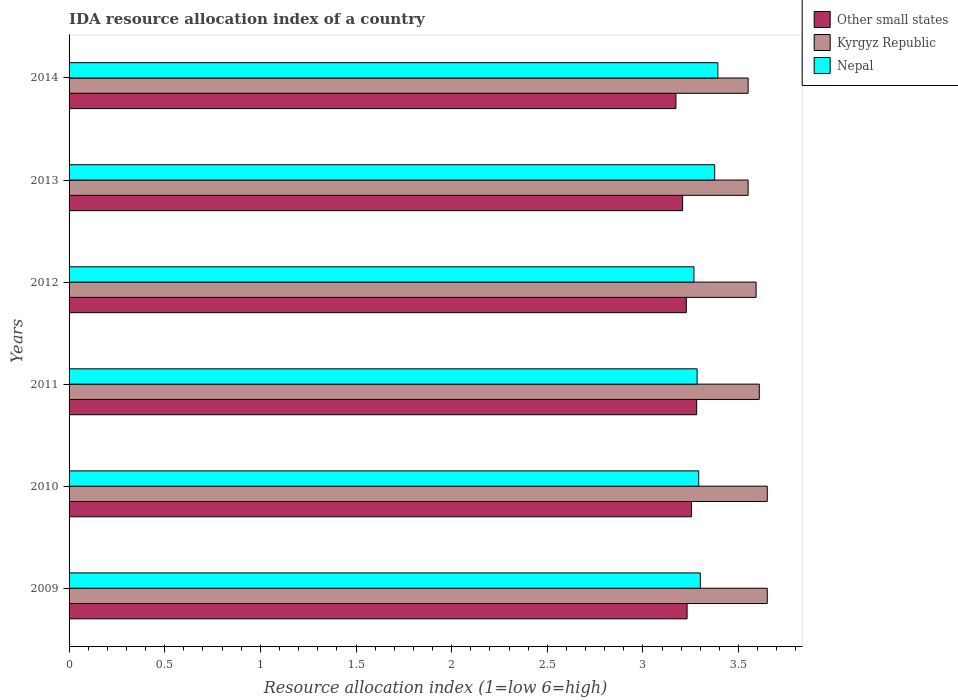How many groups of bars are there?
Offer a terse response. 6. Are the number of bars per tick equal to the number of legend labels?
Keep it short and to the point. Yes. Are the number of bars on each tick of the Y-axis equal?
Provide a succinct answer. Yes. How many bars are there on the 3rd tick from the top?
Your response must be concise. 3. How many bars are there on the 2nd tick from the bottom?
Make the answer very short. 3. What is the label of the 6th group of bars from the top?
Make the answer very short. 2009. What is the IDA resource allocation index in Kyrgyz Republic in 2012?
Make the answer very short. 3.59. Across all years, what is the maximum IDA resource allocation index in Kyrgyz Republic?
Offer a very short reply. 3.65. Across all years, what is the minimum IDA resource allocation index in Kyrgyz Republic?
Give a very brief answer. 3.55. What is the total IDA resource allocation index in Nepal in the graph?
Your answer should be very brief. 19.91. What is the difference between the IDA resource allocation index in Other small states in 2010 and that in 2013?
Ensure brevity in your answer.  0.05. What is the difference between the IDA resource allocation index in Other small states in 2009 and the IDA resource allocation index in Kyrgyz Republic in 2011?
Provide a succinct answer. -0.38. What is the average IDA resource allocation index in Other small states per year?
Ensure brevity in your answer.  3.23. In the year 2011, what is the difference between the IDA resource allocation index in Other small states and IDA resource allocation index in Kyrgyz Republic?
Provide a succinct answer. -0.33. In how many years, is the IDA resource allocation index in Nepal greater than 2.6 ?
Offer a very short reply. 6. What is the ratio of the IDA resource allocation index in Nepal in 2011 to that in 2014?
Provide a short and direct response. 0.97. What is the difference between the highest and the second highest IDA resource allocation index in Other small states?
Keep it short and to the point. 0.03. What is the difference between the highest and the lowest IDA resource allocation index in Nepal?
Your answer should be compact. 0.13. Is the sum of the IDA resource allocation index in Kyrgyz Republic in 2009 and 2010 greater than the maximum IDA resource allocation index in Nepal across all years?
Provide a succinct answer. Yes. What does the 1st bar from the top in 2011 represents?
Ensure brevity in your answer.  Nepal. What does the 2nd bar from the bottom in 2009 represents?
Ensure brevity in your answer.  Kyrgyz Republic. How many bars are there?
Your answer should be compact. 18. What is the difference between two consecutive major ticks on the X-axis?
Ensure brevity in your answer.  0.5. Does the graph contain any zero values?
Your answer should be compact. No. Where does the legend appear in the graph?
Make the answer very short. Top right. What is the title of the graph?
Offer a very short reply. IDA resource allocation index of a country. Does "Malaysia" appear as one of the legend labels in the graph?
Give a very brief answer. No. What is the label or title of the X-axis?
Provide a short and direct response. Resource allocation index (1=low 6=high). What is the Resource allocation index (1=low 6=high) in Other small states in 2009?
Make the answer very short. 3.23. What is the Resource allocation index (1=low 6=high) in Kyrgyz Republic in 2009?
Offer a terse response. 3.65. What is the Resource allocation index (1=low 6=high) in Other small states in 2010?
Keep it short and to the point. 3.25. What is the Resource allocation index (1=low 6=high) of Kyrgyz Republic in 2010?
Your answer should be very brief. 3.65. What is the Resource allocation index (1=low 6=high) of Nepal in 2010?
Your answer should be very brief. 3.29. What is the Resource allocation index (1=low 6=high) in Other small states in 2011?
Your answer should be very brief. 3.28. What is the Resource allocation index (1=low 6=high) in Kyrgyz Republic in 2011?
Your answer should be compact. 3.61. What is the Resource allocation index (1=low 6=high) of Nepal in 2011?
Make the answer very short. 3.28. What is the Resource allocation index (1=low 6=high) in Other small states in 2012?
Offer a very short reply. 3.23. What is the Resource allocation index (1=low 6=high) in Kyrgyz Republic in 2012?
Your response must be concise. 3.59. What is the Resource allocation index (1=low 6=high) in Nepal in 2012?
Your response must be concise. 3.27. What is the Resource allocation index (1=low 6=high) of Other small states in 2013?
Your answer should be compact. 3.21. What is the Resource allocation index (1=low 6=high) of Kyrgyz Republic in 2013?
Offer a very short reply. 3.55. What is the Resource allocation index (1=low 6=high) in Nepal in 2013?
Your answer should be very brief. 3.38. What is the Resource allocation index (1=low 6=high) in Other small states in 2014?
Your answer should be very brief. 3.17. What is the Resource allocation index (1=low 6=high) in Kyrgyz Republic in 2014?
Your response must be concise. 3.55. What is the Resource allocation index (1=low 6=high) of Nepal in 2014?
Offer a very short reply. 3.39. Across all years, what is the maximum Resource allocation index (1=low 6=high) in Other small states?
Offer a very short reply. 3.28. Across all years, what is the maximum Resource allocation index (1=low 6=high) of Kyrgyz Republic?
Make the answer very short. 3.65. Across all years, what is the maximum Resource allocation index (1=low 6=high) of Nepal?
Give a very brief answer. 3.39. Across all years, what is the minimum Resource allocation index (1=low 6=high) in Other small states?
Ensure brevity in your answer.  3.17. Across all years, what is the minimum Resource allocation index (1=low 6=high) of Kyrgyz Republic?
Give a very brief answer. 3.55. Across all years, what is the minimum Resource allocation index (1=low 6=high) of Nepal?
Give a very brief answer. 3.27. What is the total Resource allocation index (1=low 6=high) in Other small states in the graph?
Make the answer very short. 19.37. What is the total Resource allocation index (1=low 6=high) in Kyrgyz Republic in the graph?
Provide a succinct answer. 21.6. What is the total Resource allocation index (1=low 6=high) in Nepal in the graph?
Offer a very short reply. 19.91. What is the difference between the Resource allocation index (1=low 6=high) of Other small states in 2009 and that in 2010?
Offer a very short reply. -0.02. What is the difference between the Resource allocation index (1=low 6=high) of Kyrgyz Republic in 2009 and that in 2010?
Your answer should be very brief. 0. What is the difference between the Resource allocation index (1=low 6=high) of Nepal in 2009 and that in 2010?
Keep it short and to the point. 0.01. What is the difference between the Resource allocation index (1=low 6=high) of Other small states in 2009 and that in 2011?
Provide a succinct answer. -0.05. What is the difference between the Resource allocation index (1=low 6=high) in Kyrgyz Republic in 2009 and that in 2011?
Keep it short and to the point. 0.04. What is the difference between the Resource allocation index (1=low 6=high) of Nepal in 2009 and that in 2011?
Offer a very short reply. 0.02. What is the difference between the Resource allocation index (1=low 6=high) of Other small states in 2009 and that in 2012?
Offer a terse response. 0. What is the difference between the Resource allocation index (1=low 6=high) in Kyrgyz Republic in 2009 and that in 2012?
Offer a terse response. 0.06. What is the difference between the Resource allocation index (1=low 6=high) of Other small states in 2009 and that in 2013?
Make the answer very short. 0.02. What is the difference between the Resource allocation index (1=low 6=high) in Kyrgyz Republic in 2009 and that in 2013?
Your answer should be compact. 0.1. What is the difference between the Resource allocation index (1=low 6=high) of Nepal in 2009 and that in 2013?
Ensure brevity in your answer.  -0.07. What is the difference between the Resource allocation index (1=low 6=high) of Other small states in 2009 and that in 2014?
Provide a short and direct response. 0.06. What is the difference between the Resource allocation index (1=low 6=high) in Kyrgyz Republic in 2009 and that in 2014?
Your answer should be compact. 0.1. What is the difference between the Resource allocation index (1=low 6=high) of Nepal in 2009 and that in 2014?
Give a very brief answer. -0.09. What is the difference between the Resource allocation index (1=low 6=high) of Other small states in 2010 and that in 2011?
Your answer should be compact. -0.03. What is the difference between the Resource allocation index (1=low 6=high) of Kyrgyz Republic in 2010 and that in 2011?
Your answer should be compact. 0.04. What is the difference between the Resource allocation index (1=low 6=high) in Nepal in 2010 and that in 2011?
Provide a succinct answer. 0.01. What is the difference between the Resource allocation index (1=low 6=high) in Other small states in 2010 and that in 2012?
Make the answer very short. 0.03. What is the difference between the Resource allocation index (1=low 6=high) of Kyrgyz Republic in 2010 and that in 2012?
Make the answer very short. 0.06. What is the difference between the Resource allocation index (1=low 6=high) of Nepal in 2010 and that in 2012?
Give a very brief answer. 0.03. What is the difference between the Resource allocation index (1=low 6=high) in Other small states in 2010 and that in 2013?
Give a very brief answer. 0.05. What is the difference between the Resource allocation index (1=low 6=high) of Nepal in 2010 and that in 2013?
Make the answer very short. -0.08. What is the difference between the Resource allocation index (1=low 6=high) in Other small states in 2010 and that in 2014?
Make the answer very short. 0.08. What is the difference between the Resource allocation index (1=low 6=high) of Nepal in 2010 and that in 2014?
Give a very brief answer. -0.1. What is the difference between the Resource allocation index (1=low 6=high) in Other small states in 2011 and that in 2012?
Offer a very short reply. 0.05. What is the difference between the Resource allocation index (1=low 6=high) in Kyrgyz Republic in 2011 and that in 2012?
Ensure brevity in your answer.  0.02. What is the difference between the Resource allocation index (1=low 6=high) of Nepal in 2011 and that in 2012?
Your answer should be compact. 0.02. What is the difference between the Resource allocation index (1=low 6=high) in Other small states in 2011 and that in 2013?
Your answer should be compact. 0.07. What is the difference between the Resource allocation index (1=low 6=high) of Kyrgyz Republic in 2011 and that in 2013?
Give a very brief answer. 0.06. What is the difference between the Resource allocation index (1=low 6=high) in Nepal in 2011 and that in 2013?
Keep it short and to the point. -0.09. What is the difference between the Resource allocation index (1=low 6=high) of Other small states in 2011 and that in 2014?
Ensure brevity in your answer.  0.11. What is the difference between the Resource allocation index (1=low 6=high) of Kyrgyz Republic in 2011 and that in 2014?
Offer a very short reply. 0.06. What is the difference between the Resource allocation index (1=low 6=high) in Nepal in 2011 and that in 2014?
Give a very brief answer. -0.11. What is the difference between the Resource allocation index (1=low 6=high) in Other small states in 2012 and that in 2013?
Give a very brief answer. 0.02. What is the difference between the Resource allocation index (1=low 6=high) in Kyrgyz Republic in 2012 and that in 2013?
Your answer should be compact. 0.04. What is the difference between the Resource allocation index (1=low 6=high) in Nepal in 2012 and that in 2013?
Ensure brevity in your answer.  -0.11. What is the difference between the Resource allocation index (1=low 6=high) in Other small states in 2012 and that in 2014?
Offer a terse response. 0.05. What is the difference between the Resource allocation index (1=low 6=high) in Kyrgyz Republic in 2012 and that in 2014?
Your answer should be very brief. 0.04. What is the difference between the Resource allocation index (1=low 6=high) in Nepal in 2012 and that in 2014?
Your answer should be very brief. -0.12. What is the difference between the Resource allocation index (1=low 6=high) of Other small states in 2013 and that in 2014?
Your answer should be very brief. 0.04. What is the difference between the Resource allocation index (1=low 6=high) in Kyrgyz Republic in 2013 and that in 2014?
Make the answer very short. 0. What is the difference between the Resource allocation index (1=low 6=high) in Nepal in 2013 and that in 2014?
Offer a terse response. -0.02. What is the difference between the Resource allocation index (1=low 6=high) of Other small states in 2009 and the Resource allocation index (1=low 6=high) of Kyrgyz Republic in 2010?
Your response must be concise. -0.42. What is the difference between the Resource allocation index (1=low 6=high) of Other small states in 2009 and the Resource allocation index (1=low 6=high) of Nepal in 2010?
Your response must be concise. -0.06. What is the difference between the Resource allocation index (1=low 6=high) in Kyrgyz Republic in 2009 and the Resource allocation index (1=low 6=high) in Nepal in 2010?
Your answer should be compact. 0.36. What is the difference between the Resource allocation index (1=low 6=high) of Other small states in 2009 and the Resource allocation index (1=low 6=high) of Kyrgyz Republic in 2011?
Keep it short and to the point. -0.38. What is the difference between the Resource allocation index (1=low 6=high) of Other small states in 2009 and the Resource allocation index (1=low 6=high) of Nepal in 2011?
Your answer should be very brief. -0.05. What is the difference between the Resource allocation index (1=low 6=high) of Kyrgyz Republic in 2009 and the Resource allocation index (1=low 6=high) of Nepal in 2011?
Provide a short and direct response. 0.37. What is the difference between the Resource allocation index (1=low 6=high) in Other small states in 2009 and the Resource allocation index (1=low 6=high) in Kyrgyz Republic in 2012?
Your answer should be very brief. -0.36. What is the difference between the Resource allocation index (1=low 6=high) of Other small states in 2009 and the Resource allocation index (1=low 6=high) of Nepal in 2012?
Make the answer very short. -0.04. What is the difference between the Resource allocation index (1=low 6=high) in Kyrgyz Republic in 2009 and the Resource allocation index (1=low 6=high) in Nepal in 2012?
Your answer should be very brief. 0.38. What is the difference between the Resource allocation index (1=low 6=high) of Other small states in 2009 and the Resource allocation index (1=low 6=high) of Kyrgyz Republic in 2013?
Ensure brevity in your answer.  -0.32. What is the difference between the Resource allocation index (1=low 6=high) in Other small states in 2009 and the Resource allocation index (1=low 6=high) in Nepal in 2013?
Provide a short and direct response. -0.14. What is the difference between the Resource allocation index (1=low 6=high) in Kyrgyz Republic in 2009 and the Resource allocation index (1=low 6=high) in Nepal in 2013?
Keep it short and to the point. 0.28. What is the difference between the Resource allocation index (1=low 6=high) in Other small states in 2009 and the Resource allocation index (1=low 6=high) in Kyrgyz Republic in 2014?
Give a very brief answer. -0.32. What is the difference between the Resource allocation index (1=low 6=high) of Other small states in 2009 and the Resource allocation index (1=low 6=high) of Nepal in 2014?
Keep it short and to the point. -0.16. What is the difference between the Resource allocation index (1=low 6=high) of Kyrgyz Republic in 2009 and the Resource allocation index (1=low 6=high) of Nepal in 2014?
Provide a succinct answer. 0.26. What is the difference between the Resource allocation index (1=low 6=high) in Other small states in 2010 and the Resource allocation index (1=low 6=high) in Kyrgyz Republic in 2011?
Provide a short and direct response. -0.35. What is the difference between the Resource allocation index (1=low 6=high) in Other small states in 2010 and the Resource allocation index (1=low 6=high) in Nepal in 2011?
Keep it short and to the point. -0.03. What is the difference between the Resource allocation index (1=low 6=high) of Kyrgyz Republic in 2010 and the Resource allocation index (1=low 6=high) of Nepal in 2011?
Provide a short and direct response. 0.37. What is the difference between the Resource allocation index (1=low 6=high) in Other small states in 2010 and the Resource allocation index (1=low 6=high) in Kyrgyz Republic in 2012?
Make the answer very short. -0.34. What is the difference between the Resource allocation index (1=low 6=high) of Other small states in 2010 and the Resource allocation index (1=low 6=high) of Nepal in 2012?
Your answer should be very brief. -0.01. What is the difference between the Resource allocation index (1=low 6=high) of Kyrgyz Republic in 2010 and the Resource allocation index (1=low 6=high) of Nepal in 2012?
Your answer should be very brief. 0.38. What is the difference between the Resource allocation index (1=low 6=high) of Other small states in 2010 and the Resource allocation index (1=low 6=high) of Kyrgyz Republic in 2013?
Provide a short and direct response. -0.3. What is the difference between the Resource allocation index (1=low 6=high) of Other small states in 2010 and the Resource allocation index (1=low 6=high) of Nepal in 2013?
Your response must be concise. -0.12. What is the difference between the Resource allocation index (1=low 6=high) in Kyrgyz Republic in 2010 and the Resource allocation index (1=low 6=high) in Nepal in 2013?
Offer a terse response. 0.28. What is the difference between the Resource allocation index (1=low 6=high) of Other small states in 2010 and the Resource allocation index (1=low 6=high) of Kyrgyz Republic in 2014?
Ensure brevity in your answer.  -0.3. What is the difference between the Resource allocation index (1=low 6=high) in Other small states in 2010 and the Resource allocation index (1=low 6=high) in Nepal in 2014?
Keep it short and to the point. -0.14. What is the difference between the Resource allocation index (1=low 6=high) in Kyrgyz Republic in 2010 and the Resource allocation index (1=low 6=high) in Nepal in 2014?
Offer a terse response. 0.26. What is the difference between the Resource allocation index (1=low 6=high) in Other small states in 2011 and the Resource allocation index (1=low 6=high) in Kyrgyz Republic in 2012?
Offer a terse response. -0.31. What is the difference between the Resource allocation index (1=low 6=high) of Other small states in 2011 and the Resource allocation index (1=low 6=high) of Nepal in 2012?
Ensure brevity in your answer.  0.01. What is the difference between the Resource allocation index (1=low 6=high) of Kyrgyz Republic in 2011 and the Resource allocation index (1=low 6=high) of Nepal in 2012?
Make the answer very short. 0.34. What is the difference between the Resource allocation index (1=low 6=high) in Other small states in 2011 and the Resource allocation index (1=low 6=high) in Kyrgyz Republic in 2013?
Offer a terse response. -0.27. What is the difference between the Resource allocation index (1=low 6=high) in Other small states in 2011 and the Resource allocation index (1=low 6=high) in Nepal in 2013?
Provide a short and direct response. -0.09. What is the difference between the Resource allocation index (1=low 6=high) in Kyrgyz Republic in 2011 and the Resource allocation index (1=low 6=high) in Nepal in 2013?
Make the answer very short. 0.23. What is the difference between the Resource allocation index (1=low 6=high) in Other small states in 2011 and the Resource allocation index (1=low 6=high) in Kyrgyz Republic in 2014?
Give a very brief answer. -0.27. What is the difference between the Resource allocation index (1=low 6=high) in Other small states in 2011 and the Resource allocation index (1=low 6=high) in Nepal in 2014?
Ensure brevity in your answer.  -0.11. What is the difference between the Resource allocation index (1=low 6=high) of Kyrgyz Republic in 2011 and the Resource allocation index (1=low 6=high) of Nepal in 2014?
Keep it short and to the point. 0.22. What is the difference between the Resource allocation index (1=low 6=high) of Other small states in 2012 and the Resource allocation index (1=low 6=high) of Kyrgyz Republic in 2013?
Your answer should be compact. -0.32. What is the difference between the Resource allocation index (1=low 6=high) in Other small states in 2012 and the Resource allocation index (1=low 6=high) in Nepal in 2013?
Offer a terse response. -0.15. What is the difference between the Resource allocation index (1=low 6=high) of Kyrgyz Republic in 2012 and the Resource allocation index (1=low 6=high) of Nepal in 2013?
Your answer should be compact. 0.22. What is the difference between the Resource allocation index (1=low 6=high) of Other small states in 2012 and the Resource allocation index (1=low 6=high) of Kyrgyz Republic in 2014?
Provide a short and direct response. -0.32. What is the difference between the Resource allocation index (1=low 6=high) of Other small states in 2012 and the Resource allocation index (1=low 6=high) of Nepal in 2014?
Give a very brief answer. -0.17. What is the difference between the Resource allocation index (1=low 6=high) in Kyrgyz Republic in 2012 and the Resource allocation index (1=low 6=high) in Nepal in 2014?
Offer a very short reply. 0.2. What is the difference between the Resource allocation index (1=low 6=high) of Other small states in 2013 and the Resource allocation index (1=low 6=high) of Kyrgyz Republic in 2014?
Provide a short and direct response. -0.34. What is the difference between the Resource allocation index (1=low 6=high) in Other small states in 2013 and the Resource allocation index (1=low 6=high) in Nepal in 2014?
Your answer should be very brief. -0.18. What is the difference between the Resource allocation index (1=low 6=high) in Kyrgyz Republic in 2013 and the Resource allocation index (1=low 6=high) in Nepal in 2014?
Your answer should be very brief. 0.16. What is the average Resource allocation index (1=low 6=high) in Other small states per year?
Ensure brevity in your answer.  3.23. What is the average Resource allocation index (1=low 6=high) in Kyrgyz Republic per year?
Offer a very short reply. 3.6. What is the average Resource allocation index (1=low 6=high) in Nepal per year?
Make the answer very short. 3.32. In the year 2009, what is the difference between the Resource allocation index (1=low 6=high) of Other small states and Resource allocation index (1=low 6=high) of Kyrgyz Republic?
Provide a succinct answer. -0.42. In the year 2009, what is the difference between the Resource allocation index (1=low 6=high) of Other small states and Resource allocation index (1=low 6=high) of Nepal?
Your response must be concise. -0.07. In the year 2009, what is the difference between the Resource allocation index (1=low 6=high) in Kyrgyz Republic and Resource allocation index (1=low 6=high) in Nepal?
Your response must be concise. 0.35. In the year 2010, what is the difference between the Resource allocation index (1=low 6=high) in Other small states and Resource allocation index (1=low 6=high) in Kyrgyz Republic?
Ensure brevity in your answer.  -0.4. In the year 2010, what is the difference between the Resource allocation index (1=low 6=high) of Other small states and Resource allocation index (1=low 6=high) of Nepal?
Provide a short and direct response. -0.04. In the year 2010, what is the difference between the Resource allocation index (1=low 6=high) in Kyrgyz Republic and Resource allocation index (1=low 6=high) in Nepal?
Give a very brief answer. 0.36. In the year 2011, what is the difference between the Resource allocation index (1=low 6=high) of Other small states and Resource allocation index (1=low 6=high) of Kyrgyz Republic?
Your response must be concise. -0.33. In the year 2011, what is the difference between the Resource allocation index (1=low 6=high) in Other small states and Resource allocation index (1=low 6=high) in Nepal?
Ensure brevity in your answer.  -0. In the year 2011, what is the difference between the Resource allocation index (1=low 6=high) in Kyrgyz Republic and Resource allocation index (1=low 6=high) in Nepal?
Your answer should be very brief. 0.33. In the year 2012, what is the difference between the Resource allocation index (1=low 6=high) in Other small states and Resource allocation index (1=low 6=high) in Kyrgyz Republic?
Ensure brevity in your answer.  -0.36. In the year 2012, what is the difference between the Resource allocation index (1=low 6=high) of Other small states and Resource allocation index (1=low 6=high) of Nepal?
Keep it short and to the point. -0.04. In the year 2012, what is the difference between the Resource allocation index (1=low 6=high) in Kyrgyz Republic and Resource allocation index (1=low 6=high) in Nepal?
Make the answer very short. 0.33. In the year 2013, what is the difference between the Resource allocation index (1=low 6=high) of Other small states and Resource allocation index (1=low 6=high) of Kyrgyz Republic?
Provide a succinct answer. -0.34. In the year 2013, what is the difference between the Resource allocation index (1=low 6=high) in Other small states and Resource allocation index (1=low 6=high) in Nepal?
Offer a very short reply. -0.17. In the year 2013, what is the difference between the Resource allocation index (1=low 6=high) in Kyrgyz Republic and Resource allocation index (1=low 6=high) in Nepal?
Provide a succinct answer. 0.17. In the year 2014, what is the difference between the Resource allocation index (1=low 6=high) of Other small states and Resource allocation index (1=low 6=high) of Kyrgyz Republic?
Offer a very short reply. -0.38. In the year 2014, what is the difference between the Resource allocation index (1=low 6=high) in Other small states and Resource allocation index (1=low 6=high) in Nepal?
Your answer should be very brief. -0.22. In the year 2014, what is the difference between the Resource allocation index (1=low 6=high) of Kyrgyz Republic and Resource allocation index (1=low 6=high) of Nepal?
Your answer should be very brief. 0.16. What is the ratio of the Resource allocation index (1=low 6=high) of Kyrgyz Republic in 2009 to that in 2010?
Make the answer very short. 1. What is the ratio of the Resource allocation index (1=low 6=high) of Other small states in 2009 to that in 2011?
Your response must be concise. 0.98. What is the ratio of the Resource allocation index (1=low 6=high) in Kyrgyz Republic in 2009 to that in 2011?
Offer a terse response. 1.01. What is the ratio of the Resource allocation index (1=low 6=high) of Nepal in 2009 to that in 2011?
Keep it short and to the point. 1.01. What is the ratio of the Resource allocation index (1=low 6=high) of Other small states in 2009 to that in 2012?
Keep it short and to the point. 1. What is the ratio of the Resource allocation index (1=low 6=high) of Kyrgyz Republic in 2009 to that in 2012?
Your answer should be compact. 1.02. What is the ratio of the Resource allocation index (1=low 6=high) in Nepal in 2009 to that in 2012?
Ensure brevity in your answer.  1.01. What is the ratio of the Resource allocation index (1=low 6=high) of Other small states in 2009 to that in 2013?
Give a very brief answer. 1.01. What is the ratio of the Resource allocation index (1=low 6=high) of Kyrgyz Republic in 2009 to that in 2013?
Offer a very short reply. 1.03. What is the ratio of the Resource allocation index (1=low 6=high) in Nepal in 2009 to that in 2013?
Ensure brevity in your answer.  0.98. What is the ratio of the Resource allocation index (1=low 6=high) of Other small states in 2009 to that in 2014?
Ensure brevity in your answer.  1.02. What is the ratio of the Resource allocation index (1=low 6=high) of Kyrgyz Republic in 2009 to that in 2014?
Offer a terse response. 1.03. What is the ratio of the Resource allocation index (1=low 6=high) of Kyrgyz Republic in 2010 to that in 2011?
Offer a terse response. 1.01. What is the ratio of the Resource allocation index (1=low 6=high) in Nepal in 2010 to that in 2011?
Keep it short and to the point. 1. What is the ratio of the Resource allocation index (1=low 6=high) in Other small states in 2010 to that in 2012?
Your response must be concise. 1.01. What is the ratio of the Resource allocation index (1=low 6=high) in Kyrgyz Republic in 2010 to that in 2012?
Ensure brevity in your answer.  1.02. What is the ratio of the Resource allocation index (1=low 6=high) in Nepal in 2010 to that in 2012?
Give a very brief answer. 1.01. What is the ratio of the Resource allocation index (1=low 6=high) in Other small states in 2010 to that in 2013?
Provide a short and direct response. 1.01. What is the ratio of the Resource allocation index (1=low 6=high) in Kyrgyz Republic in 2010 to that in 2013?
Offer a very short reply. 1.03. What is the ratio of the Resource allocation index (1=low 6=high) in Nepal in 2010 to that in 2013?
Your answer should be very brief. 0.98. What is the ratio of the Resource allocation index (1=low 6=high) of Other small states in 2010 to that in 2014?
Provide a short and direct response. 1.03. What is the ratio of the Resource allocation index (1=low 6=high) in Kyrgyz Republic in 2010 to that in 2014?
Your answer should be compact. 1.03. What is the ratio of the Resource allocation index (1=low 6=high) of Nepal in 2010 to that in 2014?
Give a very brief answer. 0.97. What is the ratio of the Resource allocation index (1=low 6=high) of Other small states in 2011 to that in 2012?
Ensure brevity in your answer.  1.02. What is the ratio of the Resource allocation index (1=low 6=high) of Kyrgyz Republic in 2011 to that in 2012?
Give a very brief answer. 1. What is the ratio of the Resource allocation index (1=low 6=high) in Other small states in 2011 to that in 2013?
Ensure brevity in your answer.  1.02. What is the ratio of the Resource allocation index (1=low 6=high) of Kyrgyz Republic in 2011 to that in 2013?
Your answer should be compact. 1.02. What is the ratio of the Resource allocation index (1=low 6=high) of Nepal in 2011 to that in 2013?
Ensure brevity in your answer.  0.97. What is the ratio of the Resource allocation index (1=low 6=high) in Other small states in 2011 to that in 2014?
Provide a short and direct response. 1.03. What is the ratio of the Resource allocation index (1=low 6=high) in Kyrgyz Republic in 2011 to that in 2014?
Give a very brief answer. 1.02. What is the ratio of the Resource allocation index (1=low 6=high) in Nepal in 2011 to that in 2014?
Ensure brevity in your answer.  0.97. What is the ratio of the Resource allocation index (1=low 6=high) of Other small states in 2012 to that in 2013?
Provide a short and direct response. 1.01. What is the ratio of the Resource allocation index (1=low 6=high) of Kyrgyz Republic in 2012 to that in 2013?
Offer a very short reply. 1.01. What is the ratio of the Resource allocation index (1=low 6=high) of Nepal in 2012 to that in 2013?
Keep it short and to the point. 0.97. What is the ratio of the Resource allocation index (1=low 6=high) of Other small states in 2012 to that in 2014?
Offer a very short reply. 1.02. What is the ratio of the Resource allocation index (1=low 6=high) of Kyrgyz Republic in 2012 to that in 2014?
Provide a succinct answer. 1.01. What is the ratio of the Resource allocation index (1=low 6=high) in Nepal in 2012 to that in 2014?
Offer a very short reply. 0.96. What is the ratio of the Resource allocation index (1=low 6=high) of Kyrgyz Republic in 2013 to that in 2014?
Provide a short and direct response. 1. What is the difference between the highest and the second highest Resource allocation index (1=low 6=high) in Other small states?
Make the answer very short. 0.03. What is the difference between the highest and the second highest Resource allocation index (1=low 6=high) of Kyrgyz Republic?
Give a very brief answer. 0. What is the difference between the highest and the second highest Resource allocation index (1=low 6=high) in Nepal?
Offer a very short reply. 0.02. What is the difference between the highest and the lowest Resource allocation index (1=low 6=high) of Other small states?
Your response must be concise. 0.11. What is the difference between the highest and the lowest Resource allocation index (1=low 6=high) of Kyrgyz Republic?
Offer a very short reply. 0.1. What is the difference between the highest and the lowest Resource allocation index (1=low 6=high) in Nepal?
Keep it short and to the point. 0.12. 